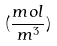Convert formula to latex. <formula><loc_0><loc_0><loc_500><loc_500>( \frac { m o l } { m ^ { 3 } } )</formula> 